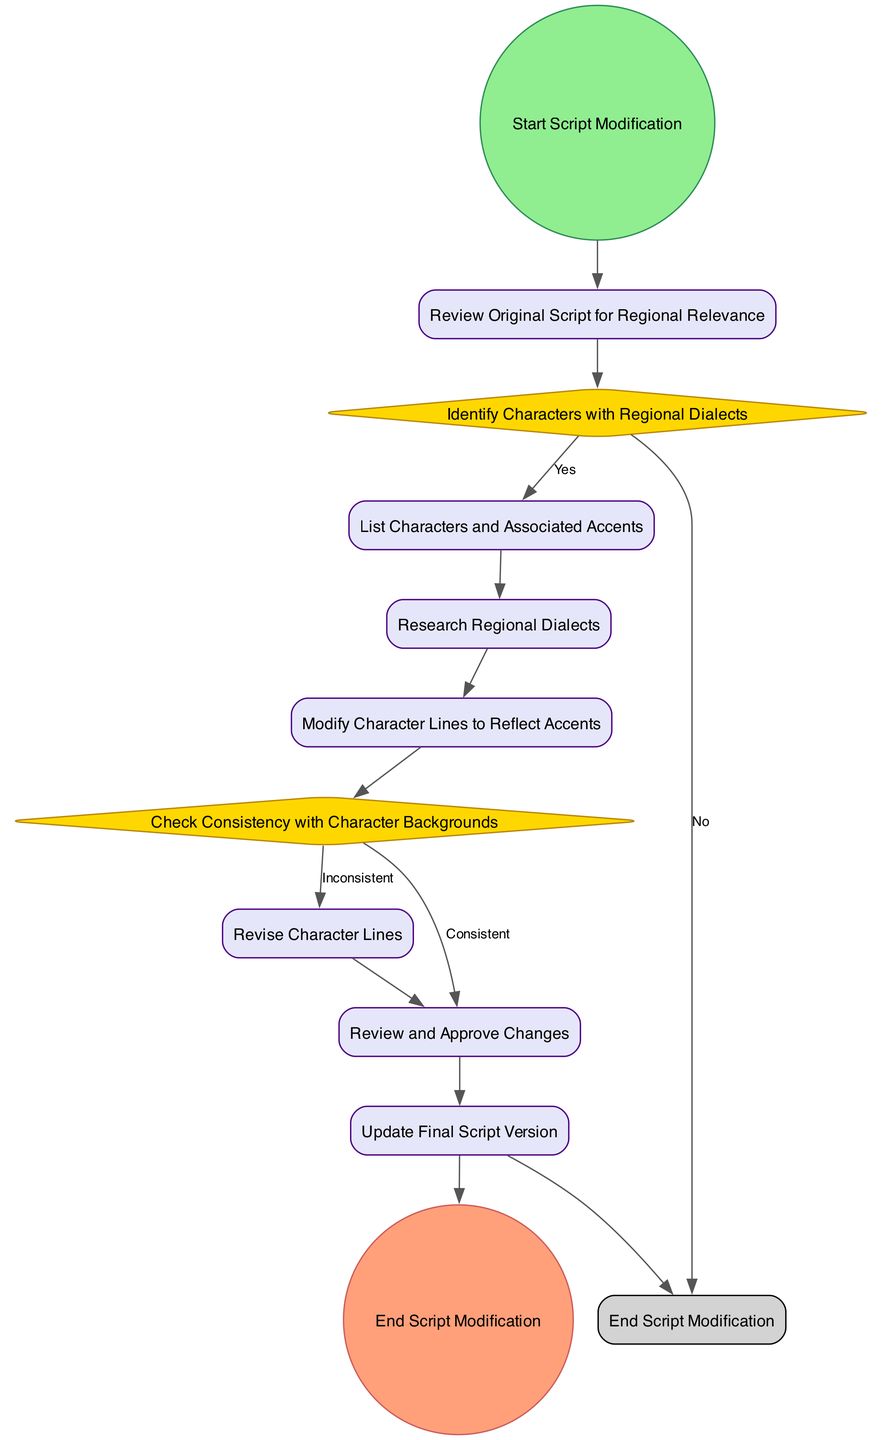What is the first step in the workflow? The first step in the workflow is the "Start Script Modification" event, which indicates the beginning of the process.
Answer: Start Script Modification How many decision points are there in the diagram? There are two decision points in the diagram: "Identify Characters with Regional Dialects" and "Check Consistency with Character Backgrounds."
Answer: 2 What happens after listing characters and associated accents? After "List Characters and Associated Accents," the next step is to "Research Regional Dialects," indicating a continuation of the workflow focused on the accents identified.
Answer: Research Regional Dialects What condition leads to the end of the script modification process? The condition that leads to the end of the process is the decision "Identify Characters with Regional Dialects" where the answer is "No." If no characters with regional dialects are identified, the script modification ends.
Answer: No Which activity follows a decision point regarding character background consistency? The activity that follows the decision point "Check Consistency with Character Backgrounds" if the characters are consistent is "Review and Approve Changes." This indicates that the changes made were accepted.
Answer: Review and Approve Changes What color represents the start event in the diagram? The start event is represented in a light green color (#90EE90), indicating the initiation of the workflow.
Answer: Light green In what scenario would the character lines be revised? The character lines would be revised if the conclusion drawn from the "Check Consistency with Character Backgrounds" decision is "Inconsistent," which indicates a contradiction that requires changes to the lines.
Answer: Inconsistent How many final steps are there before the workflow ends? There is one final step before the workflow ends, which is "Update Final Script Version," indicating that all modifications are compiled into the final document.
Answer: 1 